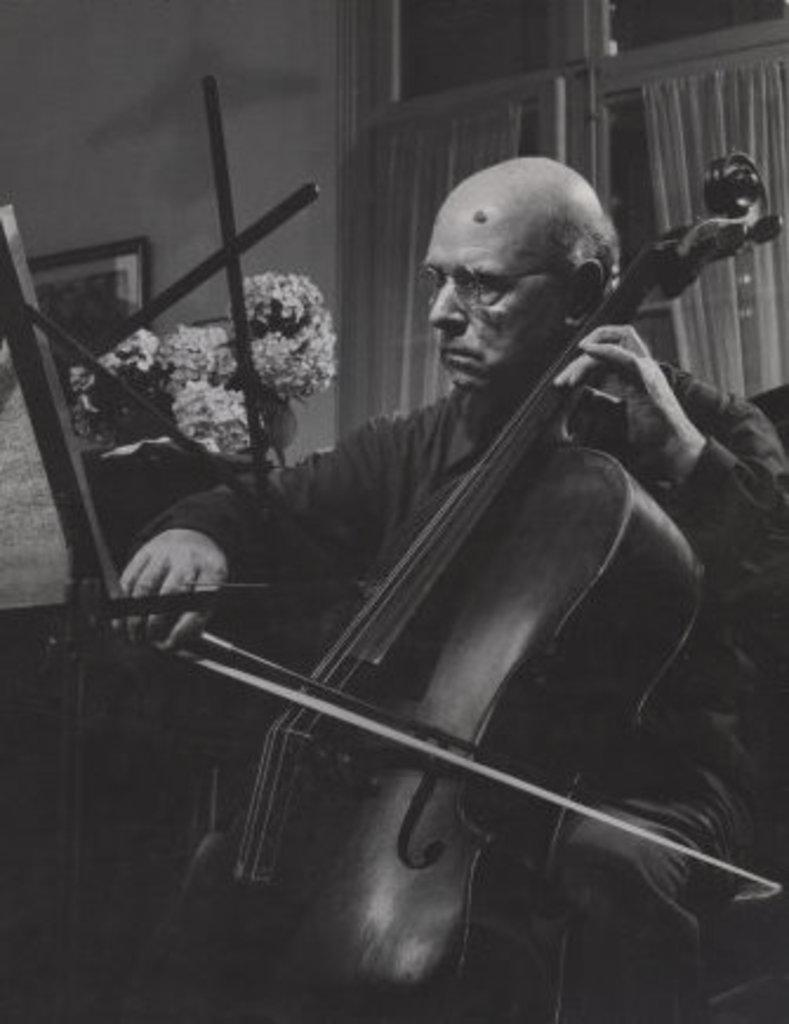What is the man in the image doing? The man is playing a violin. What is the man sitting on in the image? The man is sitting on a chair. What type of bone is the man holding in the image? There is no bone present in the image; the man is playing a violin. Is the man driving a car in the image? No, the man is not driving a car in the image; he is sitting on a chair and playing a violin. 